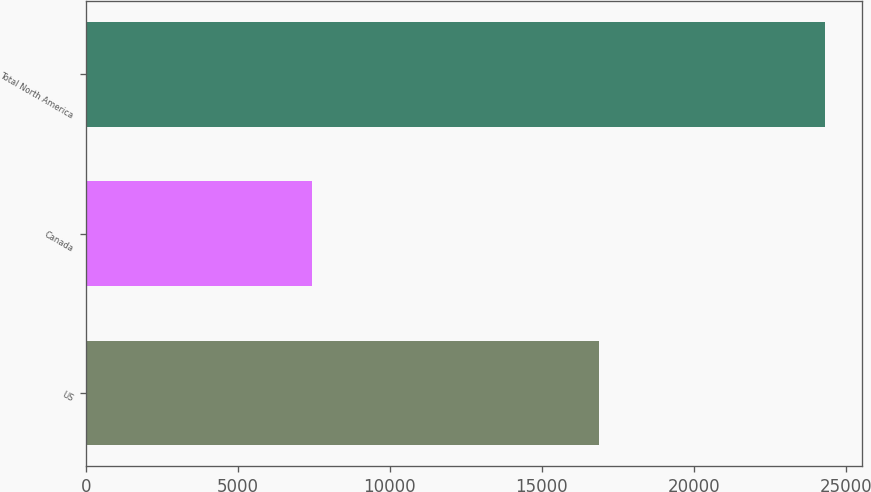Convert chart to OTSL. <chart><loc_0><loc_0><loc_500><loc_500><bar_chart><fcel>US<fcel>Canada<fcel>Total North America<nl><fcel>16874<fcel>7439<fcel>24313<nl></chart> 